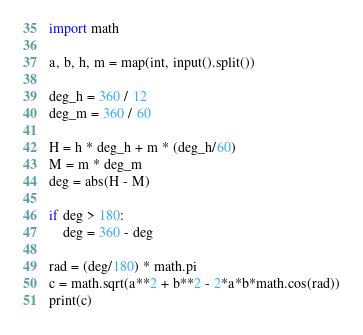<code> <loc_0><loc_0><loc_500><loc_500><_Python_>import math

a, b, h, m = map(int, input().split())

deg_h = 360 / 12
deg_m = 360 / 60

H = h * deg_h + m * (deg_h/60)
M = m * deg_m
deg = abs(H - M)

if deg > 180:
    deg = 360 - deg

rad = (deg/180) * math.pi
c = math.sqrt(a**2 + b**2 - 2*a*b*math.cos(rad))
print(c)
</code> 